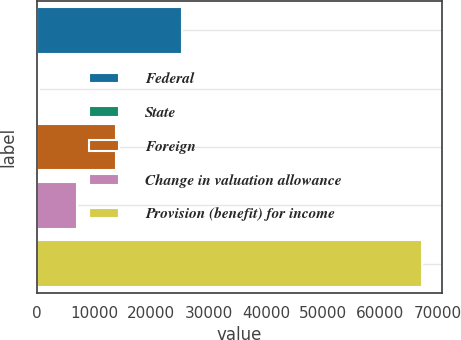Convert chart to OTSL. <chart><loc_0><loc_0><loc_500><loc_500><bar_chart><fcel>Federal<fcel>State<fcel>Foreign<fcel>Change in valuation allowance<fcel>Provision (benefit) for income<nl><fcel>25421<fcel>422<fcel>13797.8<fcel>7109.9<fcel>67301<nl></chart> 